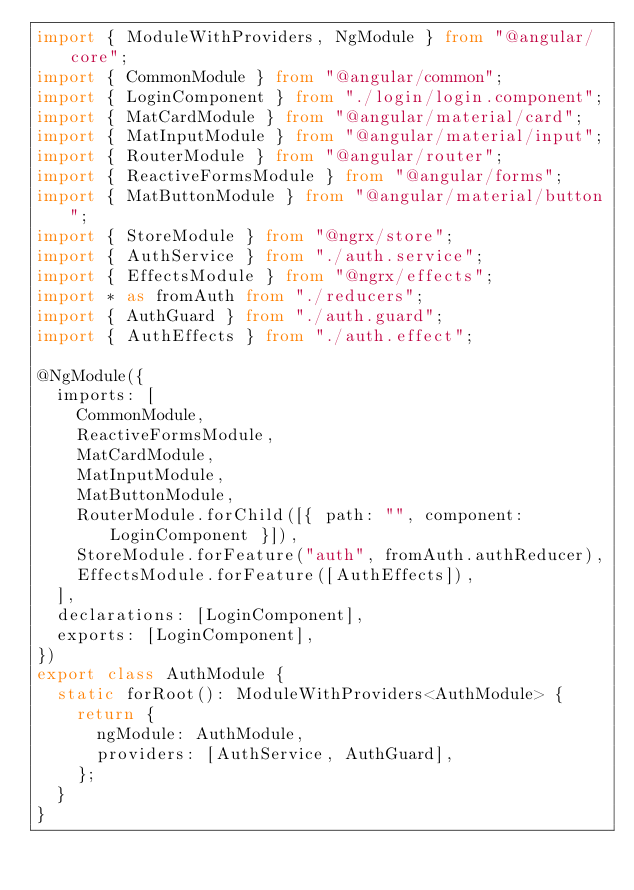Convert code to text. <code><loc_0><loc_0><loc_500><loc_500><_TypeScript_>import { ModuleWithProviders, NgModule } from "@angular/core";
import { CommonModule } from "@angular/common";
import { LoginComponent } from "./login/login.component";
import { MatCardModule } from "@angular/material/card";
import { MatInputModule } from "@angular/material/input";
import { RouterModule } from "@angular/router";
import { ReactiveFormsModule } from "@angular/forms";
import { MatButtonModule } from "@angular/material/button";
import { StoreModule } from "@ngrx/store";
import { AuthService } from "./auth.service";
import { EffectsModule } from "@ngrx/effects";
import * as fromAuth from "./reducers";
import { AuthGuard } from "./auth.guard";
import { AuthEffects } from "./auth.effect";

@NgModule({
  imports: [
    CommonModule,
    ReactiveFormsModule,
    MatCardModule,
    MatInputModule,
    MatButtonModule,
    RouterModule.forChild([{ path: "", component: LoginComponent }]),
    StoreModule.forFeature("auth", fromAuth.authReducer),
    EffectsModule.forFeature([AuthEffects]),
  ],
  declarations: [LoginComponent],
  exports: [LoginComponent],
})
export class AuthModule {
  static forRoot(): ModuleWithProviders<AuthModule> {
    return {
      ngModule: AuthModule,
      providers: [AuthService, AuthGuard],
    };
  }
}
</code> 